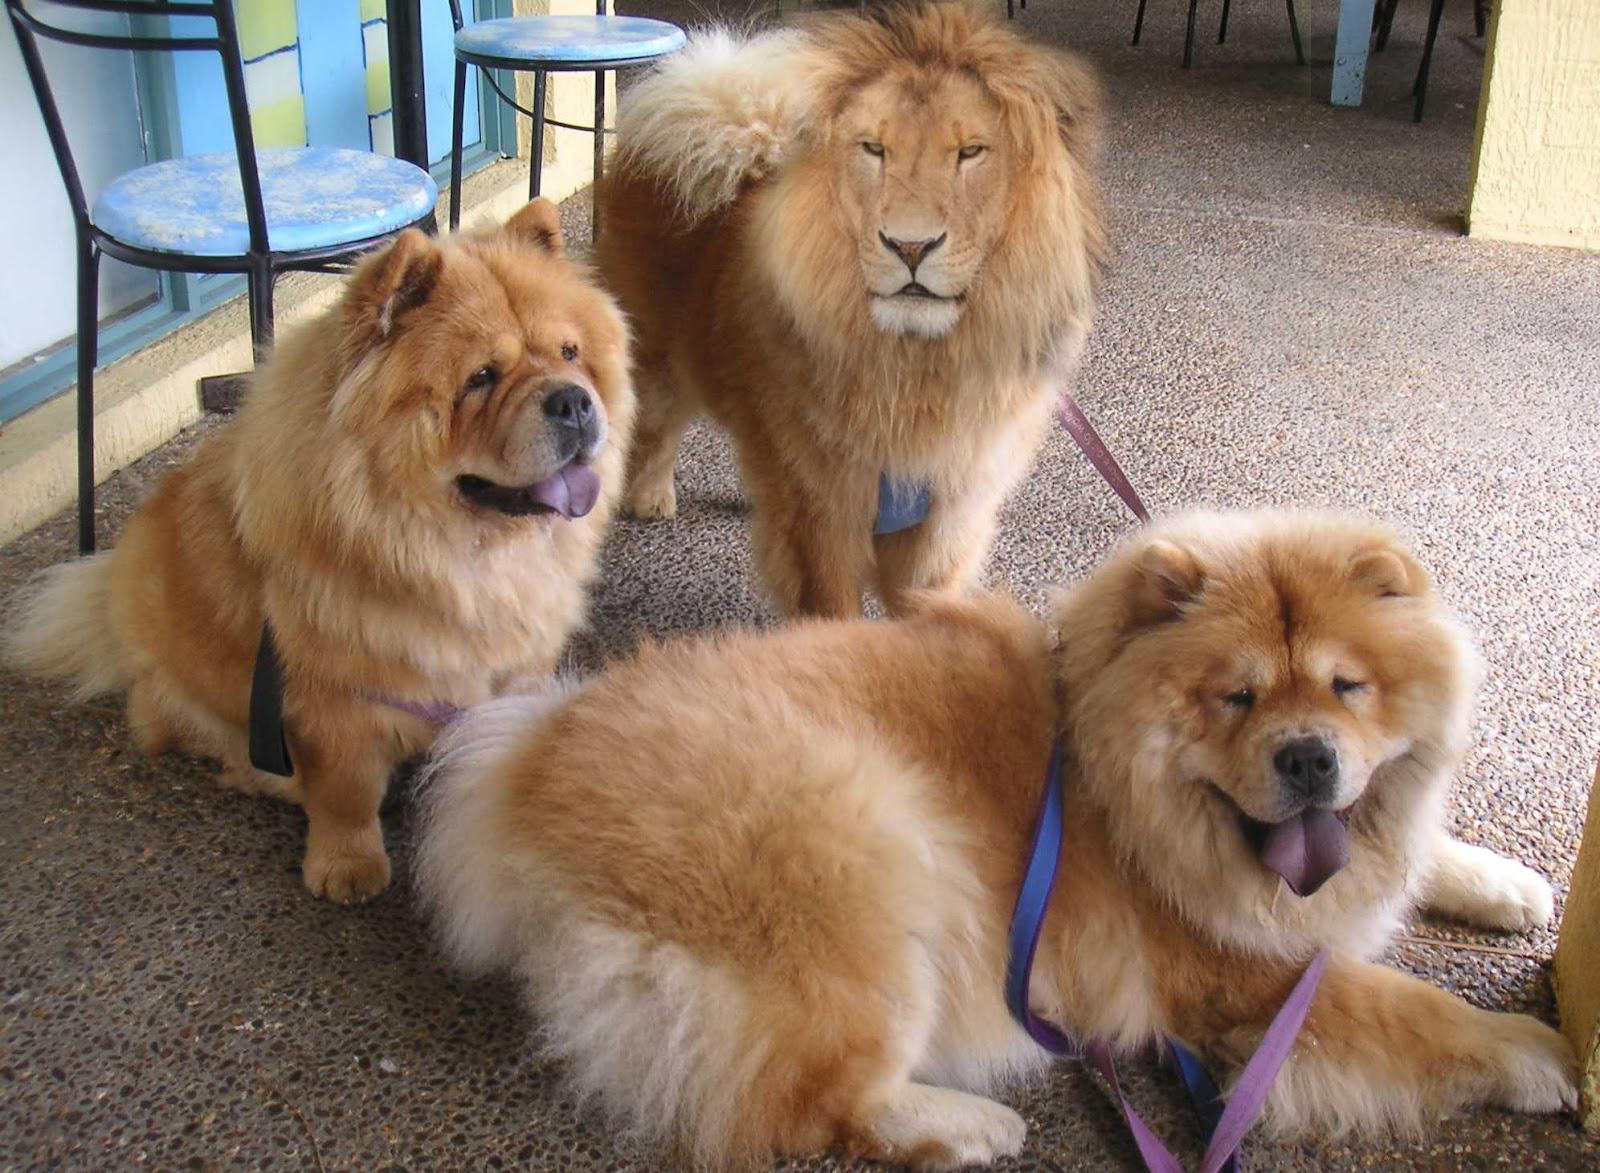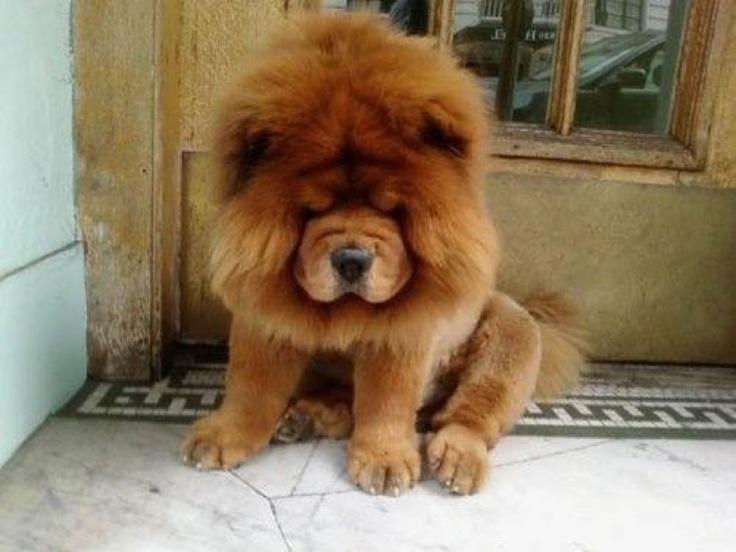The first image is the image on the left, the second image is the image on the right. Considering the images on both sides, is "The left image contains at least two chow dogs." valid? Answer yes or no. Yes. The first image is the image on the left, the second image is the image on the right. For the images shown, is this caption "There are more living dogs in the image on the left." true? Answer yes or no. Yes. 